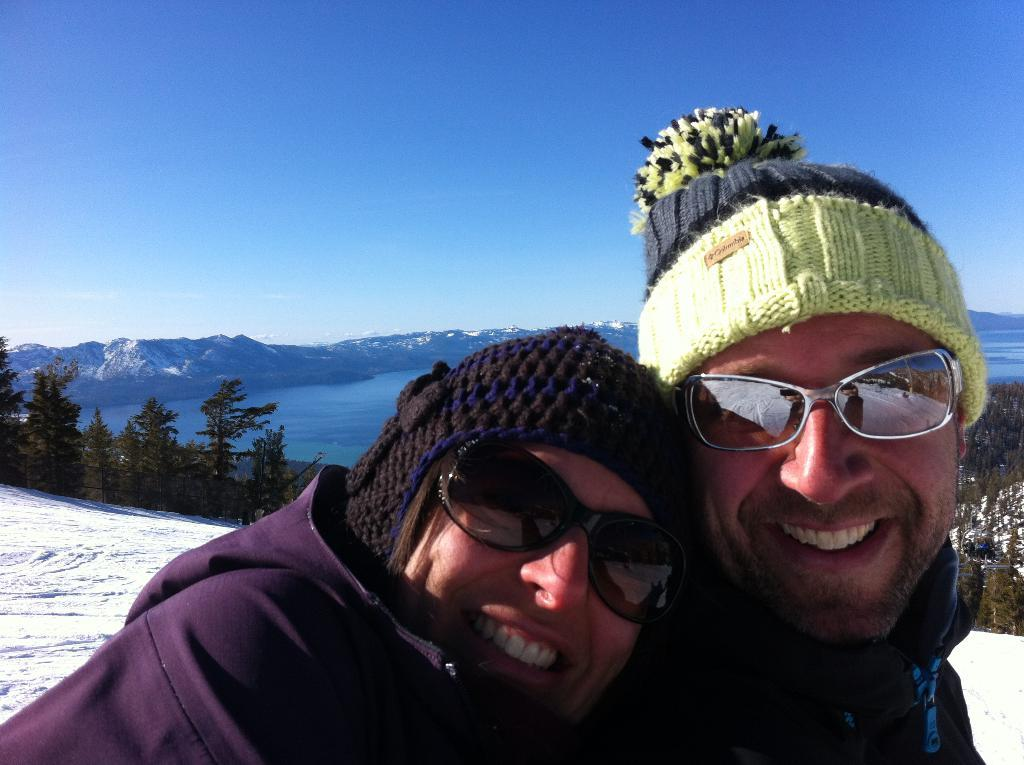How many people are in the image? There are two persons in the image. What is the facial expression of the persons in the image? The persons are smiling. What can be seen in the background of the image? There are mountains, trees, and water visible in the background of the image. What is the condition of the sky in the image? The sky is visible at the top of the image. What type of terrain is present at the bottom of the image? There is snow at the bottom of the image. What invention can be seen being used by the persons in the image? There is no invention visible in the image; the persons are simply standing and smiling. What reward is the person on the left receiving for their actions in the image? There is no reward being given in the image, as it only shows two people smiling and no specific actions are being performed. 